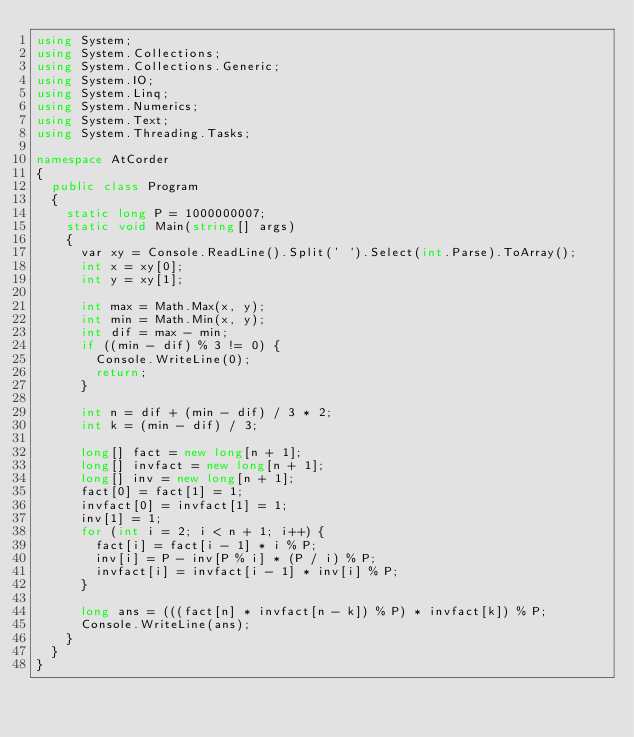Convert code to text. <code><loc_0><loc_0><loc_500><loc_500><_C#_>using System;
using System.Collections;
using System.Collections.Generic;
using System.IO;
using System.Linq;
using System.Numerics;
using System.Text;
using System.Threading.Tasks;

namespace AtCorder
{
	public class Program
	{
		static long P = 1000000007;
		static void Main(string[] args)
		{
			var xy = Console.ReadLine().Split(' ').Select(int.Parse).ToArray();
			int x = xy[0];
			int y = xy[1];

			int max = Math.Max(x, y);
			int min = Math.Min(x, y);
			int dif = max - min;
			if ((min - dif) % 3 != 0) {
				Console.WriteLine(0);
				return;
			}

			int n = dif + (min - dif) / 3 * 2;
			int k = (min - dif) / 3;

			long[] fact = new long[n + 1];
			long[] invfact = new long[n + 1];
			long[] inv = new long[n + 1];
			fact[0] = fact[1] = 1;
			invfact[0] = invfact[1] = 1;
			inv[1] = 1;
			for (int i = 2; i < n + 1; i++) {
				fact[i] = fact[i - 1] * i % P;
				inv[i] = P - inv[P % i] * (P / i) % P;
				invfact[i] = invfact[i - 1] * inv[i] % P;
			}

			long ans = (((fact[n] * invfact[n - k]) % P) * invfact[k]) % P;
			Console.WriteLine(ans);
		}
	}
}</code> 